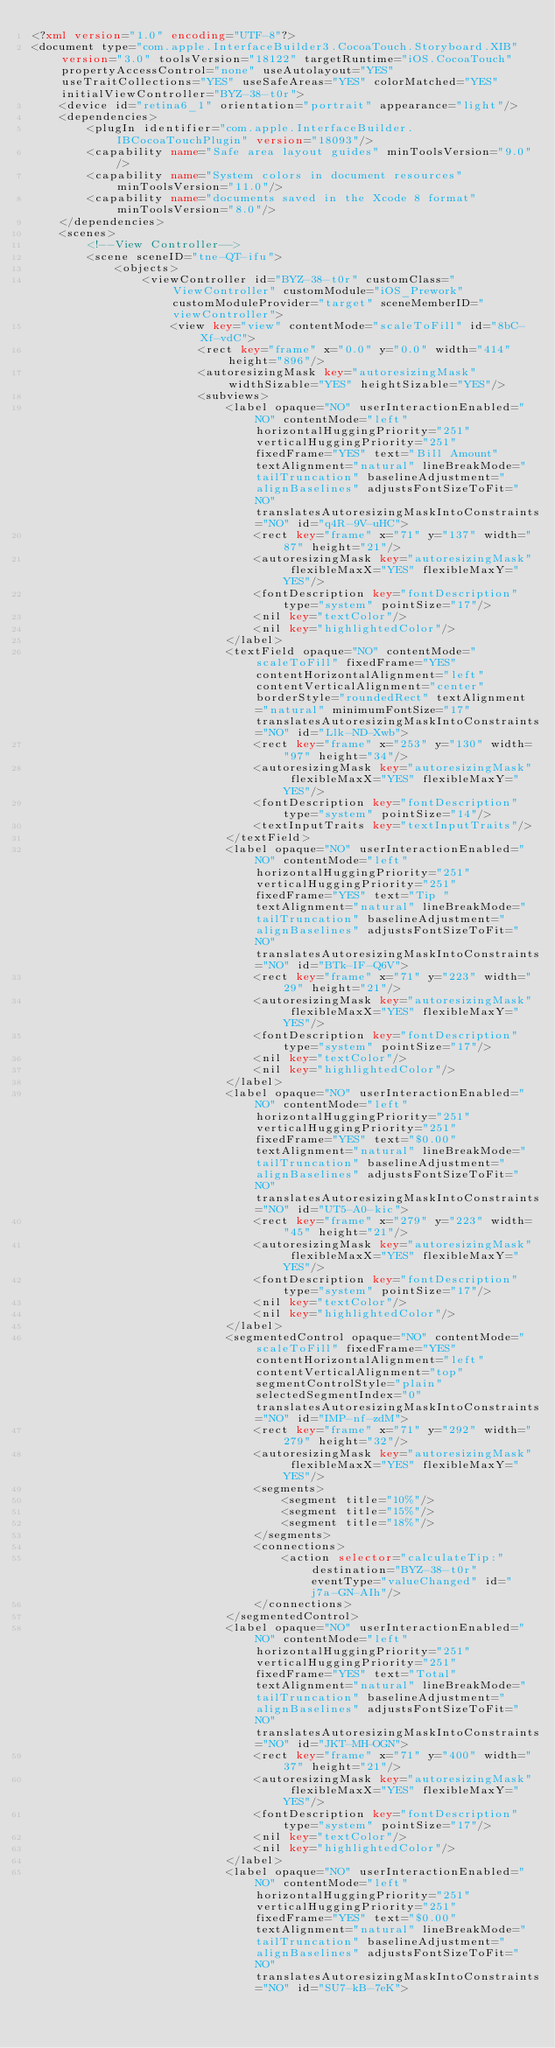Convert code to text. <code><loc_0><loc_0><loc_500><loc_500><_XML_><?xml version="1.0" encoding="UTF-8"?>
<document type="com.apple.InterfaceBuilder3.CocoaTouch.Storyboard.XIB" version="3.0" toolsVersion="18122" targetRuntime="iOS.CocoaTouch" propertyAccessControl="none" useAutolayout="YES" useTraitCollections="YES" useSafeAreas="YES" colorMatched="YES" initialViewController="BYZ-38-t0r">
    <device id="retina6_1" orientation="portrait" appearance="light"/>
    <dependencies>
        <plugIn identifier="com.apple.InterfaceBuilder.IBCocoaTouchPlugin" version="18093"/>
        <capability name="Safe area layout guides" minToolsVersion="9.0"/>
        <capability name="System colors in document resources" minToolsVersion="11.0"/>
        <capability name="documents saved in the Xcode 8 format" minToolsVersion="8.0"/>
    </dependencies>
    <scenes>
        <!--View Controller-->
        <scene sceneID="tne-QT-ifu">
            <objects>
                <viewController id="BYZ-38-t0r" customClass="ViewController" customModule="iOS_Prework" customModuleProvider="target" sceneMemberID="viewController">
                    <view key="view" contentMode="scaleToFill" id="8bC-Xf-vdC">
                        <rect key="frame" x="0.0" y="0.0" width="414" height="896"/>
                        <autoresizingMask key="autoresizingMask" widthSizable="YES" heightSizable="YES"/>
                        <subviews>
                            <label opaque="NO" userInteractionEnabled="NO" contentMode="left" horizontalHuggingPriority="251" verticalHuggingPriority="251" fixedFrame="YES" text="Bill Amount" textAlignment="natural" lineBreakMode="tailTruncation" baselineAdjustment="alignBaselines" adjustsFontSizeToFit="NO" translatesAutoresizingMaskIntoConstraints="NO" id="q4R-9V-uHC">
                                <rect key="frame" x="71" y="137" width="87" height="21"/>
                                <autoresizingMask key="autoresizingMask" flexibleMaxX="YES" flexibleMaxY="YES"/>
                                <fontDescription key="fontDescription" type="system" pointSize="17"/>
                                <nil key="textColor"/>
                                <nil key="highlightedColor"/>
                            </label>
                            <textField opaque="NO" contentMode="scaleToFill" fixedFrame="YES" contentHorizontalAlignment="left" contentVerticalAlignment="center" borderStyle="roundedRect" textAlignment="natural" minimumFontSize="17" translatesAutoresizingMaskIntoConstraints="NO" id="Llk-ND-Xwb">
                                <rect key="frame" x="253" y="130" width="97" height="34"/>
                                <autoresizingMask key="autoresizingMask" flexibleMaxX="YES" flexibleMaxY="YES"/>
                                <fontDescription key="fontDescription" type="system" pointSize="14"/>
                                <textInputTraits key="textInputTraits"/>
                            </textField>
                            <label opaque="NO" userInteractionEnabled="NO" contentMode="left" horizontalHuggingPriority="251" verticalHuggingPriority="251" fixedFrame="YES" text="Tip " textAlignment="natural" lineBreakMode="tailTruncation" baselineAdjustment="alignBaselines" adjustsFontSizeToFit="NO" translatesAutoresizingMaskIntoConstraints="NO" id="BTk-IF-Q6V">
                                <rect key="frame" x="71" y="223" width="29" height="21"/>
                                <autoresizingMask key="autoresizingMask" flexibleMaxX="YES" flexibleMaxY="YES"/>
                                <fontDescription key="fontDescription" type="system" pointSize="17"/>
                                <nil key="textColor"/>
                                <nil key="highlightedColor"/>
                            </label>
                            <label opaque="NO" userInteractionEnabled="NO" contentMode="left" horizontalHuggingPriority="251" verticalHuggingPriority="251" fixedFrame="YES" text="$0.00" textAlignment="natural" lineBreakMode="tailTruncation" baselineAdjustment="alignBaselines" adjustsFontSizeToFit="NO" translatesAutoresizingMaskIntoConstraints="NO" id="UT5-A0-kic">
                                <rect key="frame" x="279" y="223" width="45" height="21"/>
                                <autoresizingMask key="autoresizingMask" flexibleMaxX="YES" flexibleMaxY="YES"/>
                                <fontDescription key="fontDescription" type="system" pointSize="17"/>
                                <nil key="textColor"/>
                                <nil key="highlightedColor"/>
                            </label>
                            <segmentedControl opaque="NO" contentMode="scaleToFill" fixedFrame="YES" contentHorizontalAlignment="left" contentVerticalAlignment="top" segmentControlStyle="plain" selectedSegmentIndex="0" translatesAutoresizingMaskIntoConstraints="NO" id="IMP-nf-zdM">
                                <rect key="frame" x="71" y="292" width="279" height="32"/>
                                <autoresizingMask key="autoresizingMask" flexibleMaxX="YES" flexibleMaxY="YES"/>
                                <segments>
                                    <segment title="10%"/>
                                    <segment title="15%"/>
                                    <segment title="18%"/>
                                </segments>
                                <connections>
                                    <action selector="calculateTip:" destination="BYZ-38-t0r" eventType="valueChanged" id="j7a-GN-AIh"/>
                                </connections>
                            </segmentedControl>
                            <label opaque="NO" userInteractionEnabled="NO" contentMode="left" horizontalHuggingPriority="251" verticalHuggingPriority="251" fixedFrame="YES" text="Total" textAlignment="natural" lineBreakMode="tailTruncation" baselineAdjustment="alignBaselines" adjustsFontSizeToFit="NO" translatesAutoresizingMaskIntoConstraints="NO" id="JKT-MH-OGN">
                                <rect key="frame" x="71" y="400" width="37" height="21"/>
                                <autoresizingMask key="autoresizingMask" flexibleMaxX="YES" flexibleMaxY="YES"/>
                                <fontDescription key="fontDescription" type="system" pointSize="17"/>
                                <nil key="textColor"/>
                                <nil key="highlightedColor"/>
                            </label>
                            <label opaque="NO" userInteractionEnabled="NO" contentMode="left" horizontalHuggingPriority="251" verticalHuggingPriority="251" fixedFrame="YES" text="$0.00" textAlignment="natural" lineBreakMode="tailTruncation" baselineAdjustment="alignBaselines" adjustsFontSizeToFit="NO" translatesAutoresizingMaskIntoConstraints="NO" id="SU7-kB-7eK"></code> 